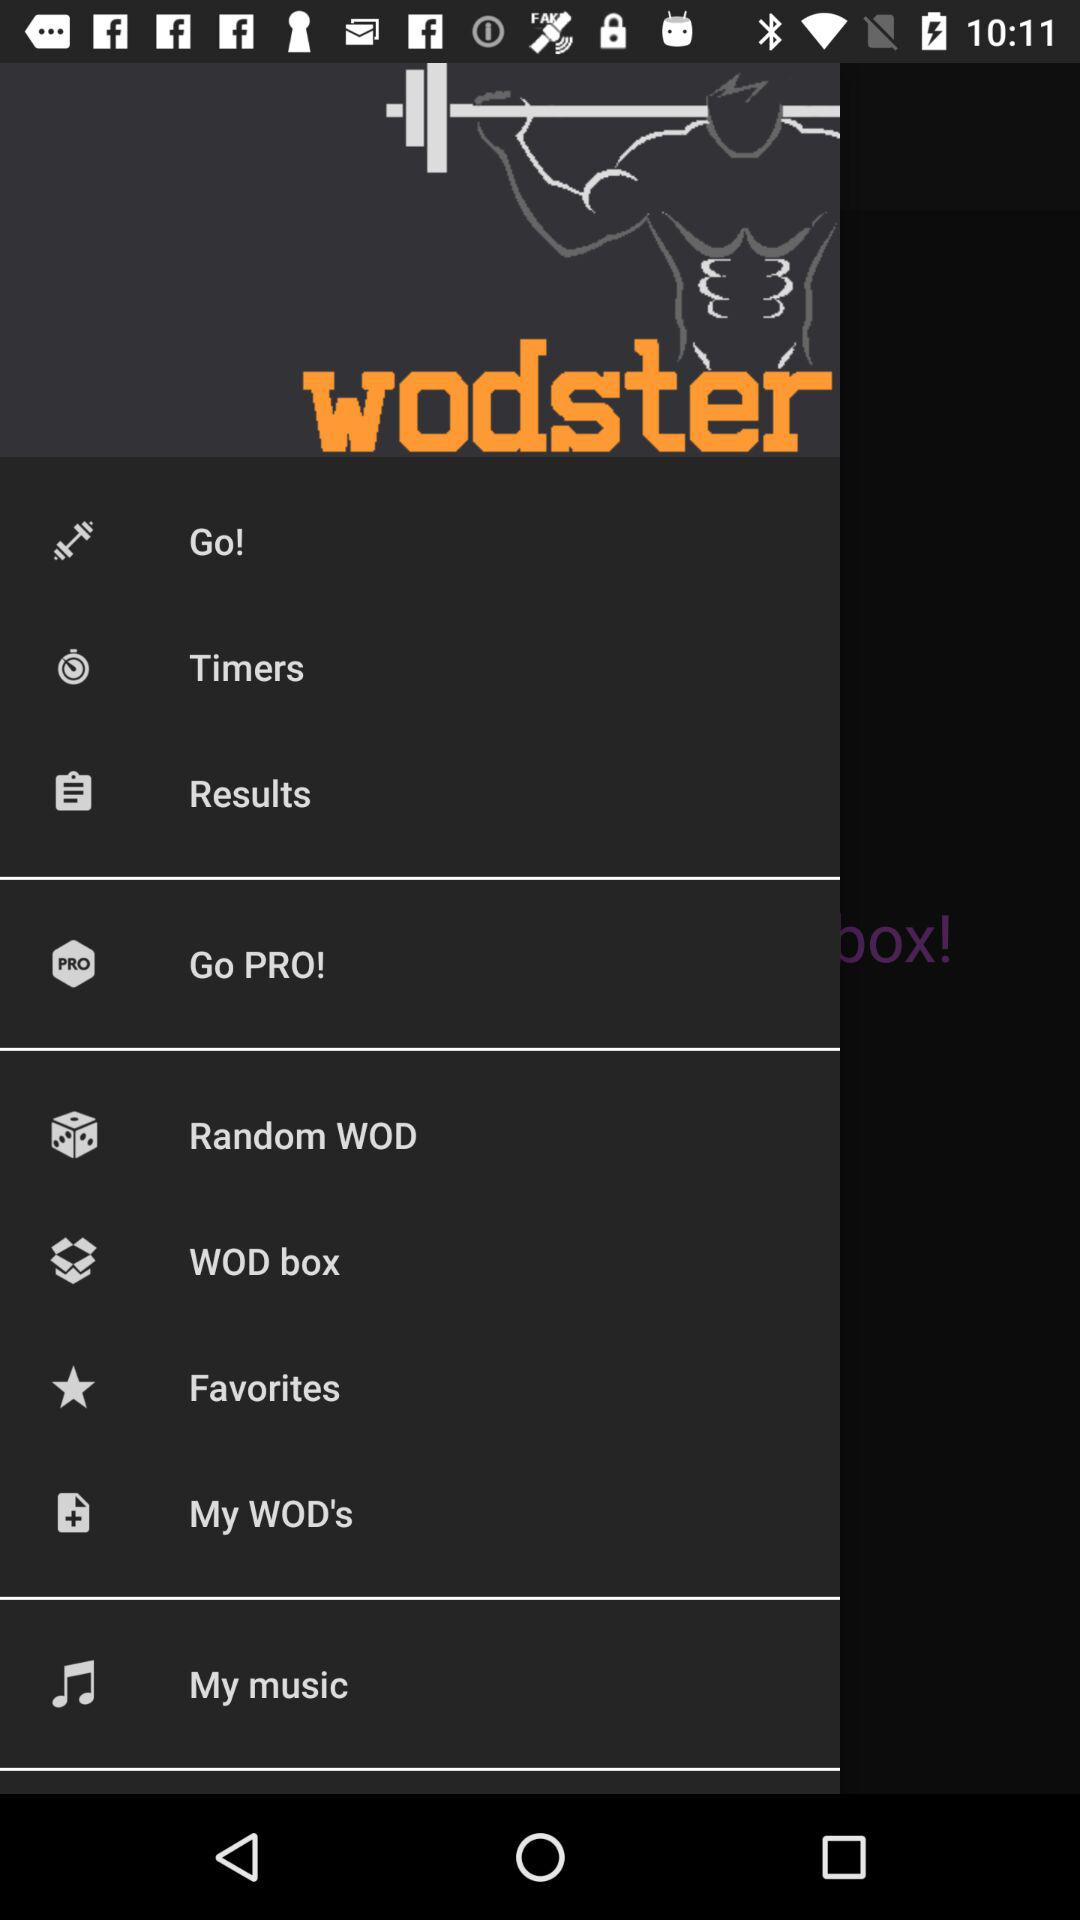What is the name of the application? The name of the application is "wodster". 